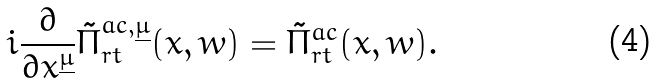Convert formula to latex. <formula><loc_0><loc_0><loc_500><loc_500>i \frac { \partial } { \partial x ^ { \underline { \mu } } } \tilde { \Pi } _ { r t } ^ { a c , \underline { \mu } } ( x , w ) = \tilde { \Pi } _ { r t } ^ { a c } ( x , w ) .</formula> 